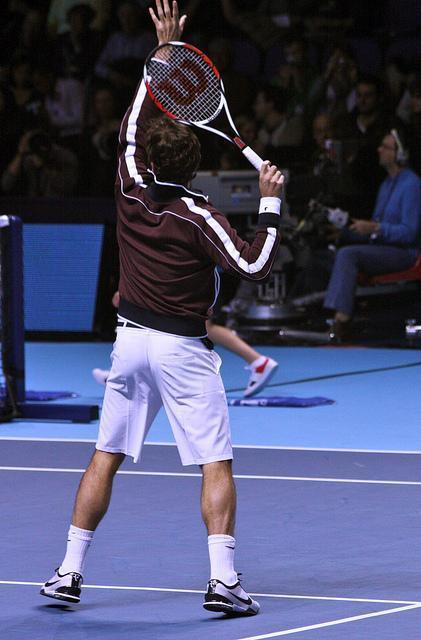How many people are in the picture?
Give a very brief answer. 7. How many tennis rackets are there?
Give a very brief answer. 1. 